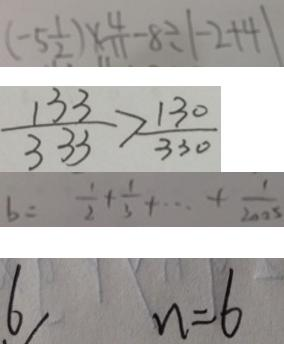Convert formula to latex. <formula><loc_0><loc_0><loc_500><loc_500>( - 5 \frac { 1 } { 2 } ) \times \frac { 4 } { 1 1 } - 8 \div \vert - 2 + 4 \vert 
 \frac { 1 3 3 } { 3 3 3 } > \frac { 1 3 0 } { 3 3 0 } 
 b = \frac { 1 } { 2 } + \frac { 1 } { 3 } + \cdots + \frac { 1 } { 2 0 0 5 } 
 6 n = 6</formula> 